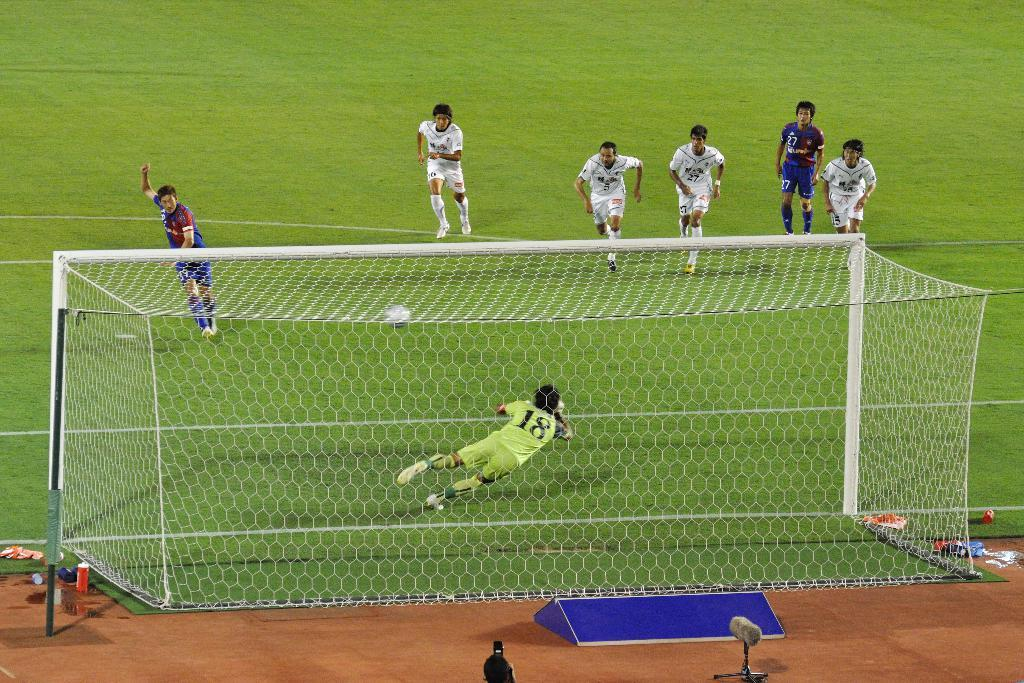<image>
Describe the image concisely. A goalie with a green uniform and the number 18 on his back is about to block a shot. 